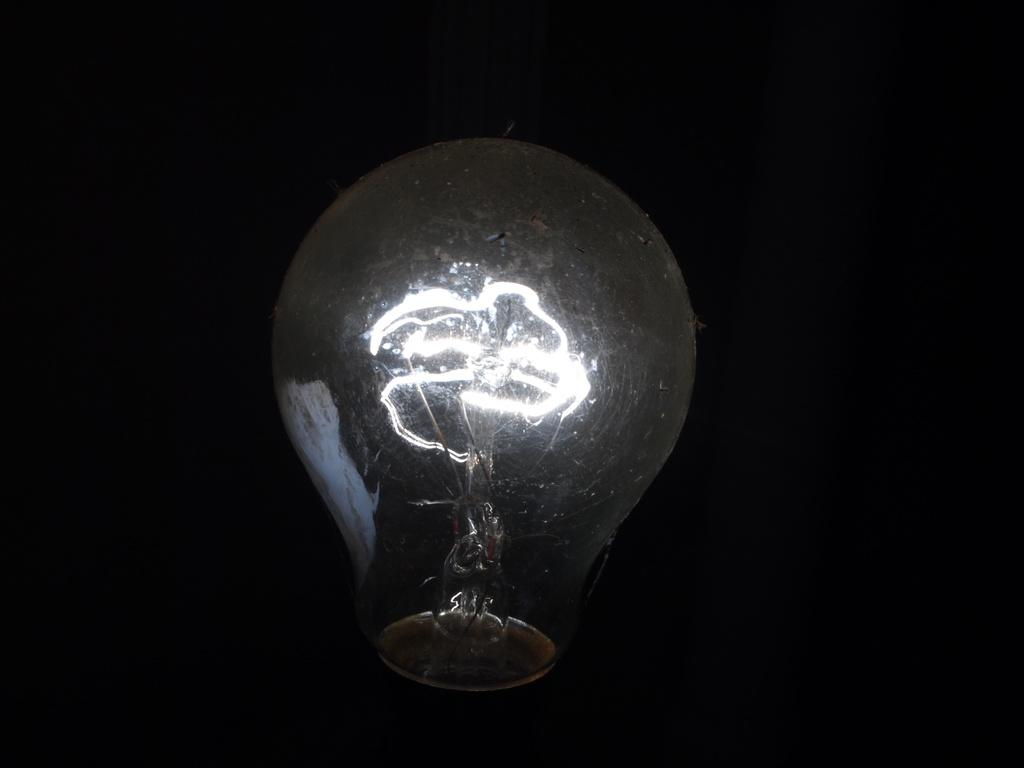What is the main object in the image? There is a bulb in the image. How many babies are present in the image? There are no babies present in the image; it only features a bulb. What type of calculator is being used in the image? There is no calculator present in the image; it only features a bulb. 